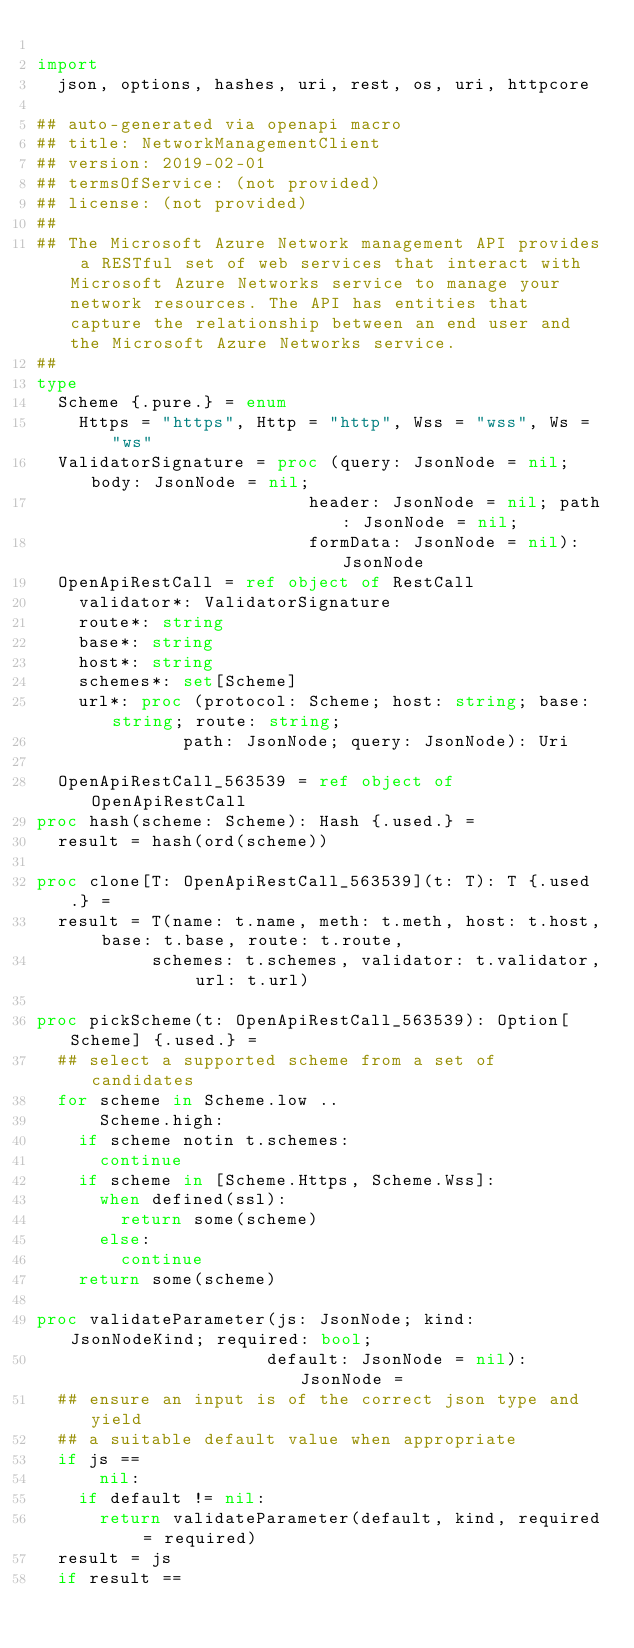Convert code to text. <code><loc_0><loc_0><loc_500><loc_500><_Nim_>
import
  json, options, hashes, uri, rest, os, uri, httpcore

## auto-generated via openapi macro
## title: NetworkManagementClient
## version: 2019-02-01
## termsOfService: (not provided)
## license: (not provided)
## 
## The Microsoft Azure Network management API provides a RESTful set of web services that interact with Microsoft Azure Networks service to manage your network resources. The API has entities that capture the relationship between an end user and the Microsoft Azure Networks service.
## 
type
  Scheme {.pure.} = enum
    Https = "https", Http = "http", Wss = "wss", Ws = "ws"
  ValidatorSignature = proc (query: JsonNode = nil; body: JsonNode = nil;
                          header: JsonNode = nil; path: JsonNode = nil;
                          formData: JsonNode = nil): JsonNode
  OpenApiRestCall = ref object of RestCall
    validator*: ValidatorSignature
    route*: string
    base*: string
    host*: string
    schemes*: set[Scheme]
    url*: proc (protocol: Scheme; host: string; base: string; route: string;
              path: JsonNode; query: JsonNode): Uri

  OpenApiRestCall_563539 = ref object of OpenApiRestCall
proc hash(scheme: Scheme): Hash {.used.} =
  result = hash(ord(scheme))

proc clone[T: OpenApiRestCall_563539](t: T): T {.used.} =
  result = T(name: t.name, meth: t.meth, host: t.host, base: t.base, route: t.route,
           schemes: t.schemes, validator: t.validator, url: t.url)

proc pickScheme(t: OpenApiRestCall_563539): Option[Scheme] {.used.} =
  ## select a supported scheme from a set of candidates
  for scheme in Scheme.low ..
      Scheme.high:
    if scheme notin t.schemes:
      continue
    if scheme in [Scheme.Https, Scheme.Wss]:
      when defined(ssl):
        return some(scheme)
      else:
        continue
    return some(scheme)

proc validateParameter(js: JsonNode; kind: JsonNodeKind; required: bool;
                      default: JsonNode = nil): JsonNode =
  ## ensure an input is of the correct json type and yield
  ## a suitable default value when appropriate
  if js ==
      nil:
    if default != nil:
      return validateParameter(default, kind, required = required)
  result = js
  if result ==</code> 